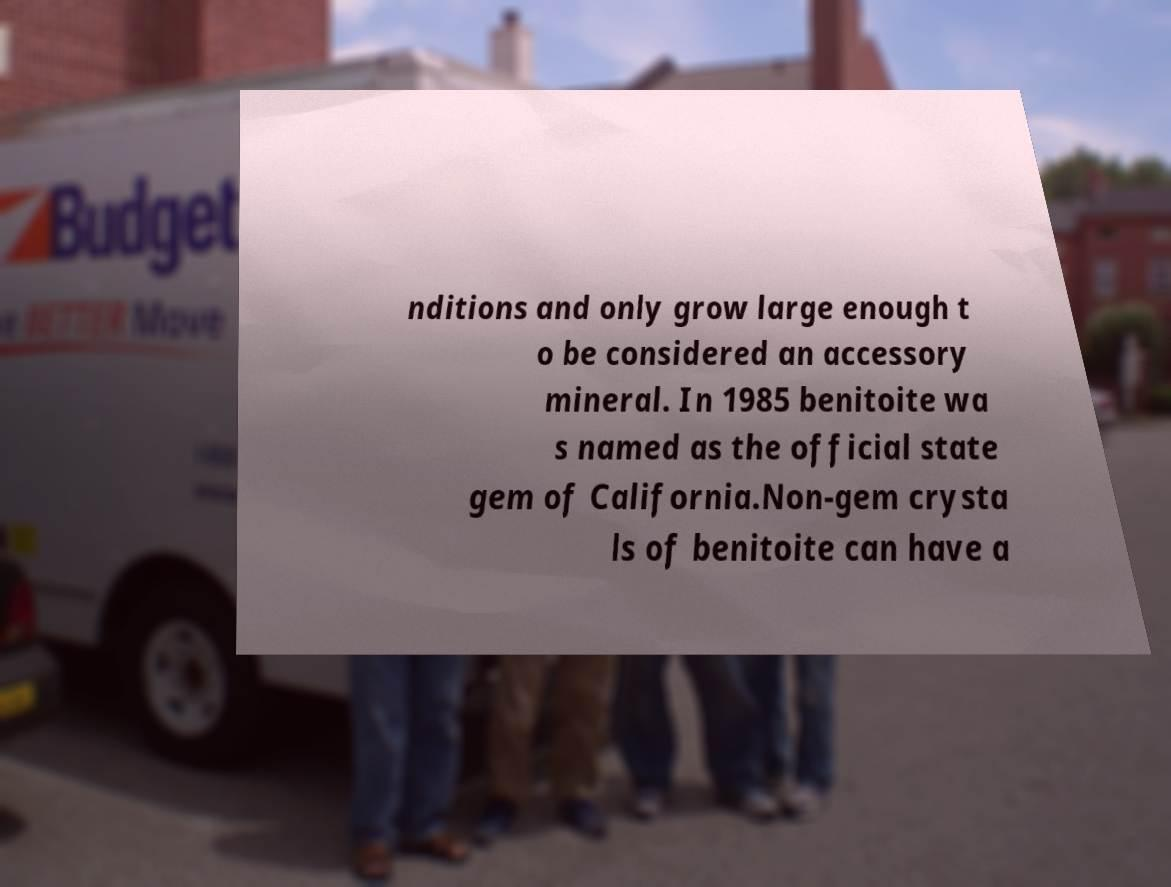What messages or text are displayed in this image? I need them in a readable, typed format. nditions and only grow large enough t o be considered an accessory mineral. In 1985 benitoite wa s named as the official state gem of California.Non-gem crysta ls of benitoite can have a 